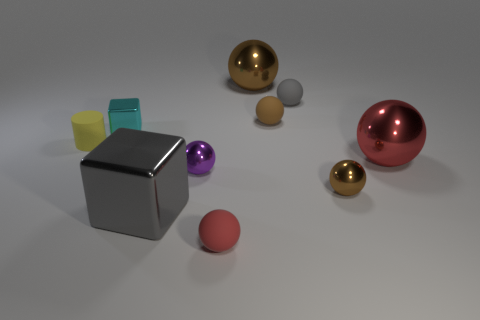Could you guess the purpose of the arrangement of these objects? The purpose of the arrangement is not apparent, which suggests it may be an abstract composition, designed for visual or artistic experimentation, possibly exploring geometry, color contrast, and reflections. 